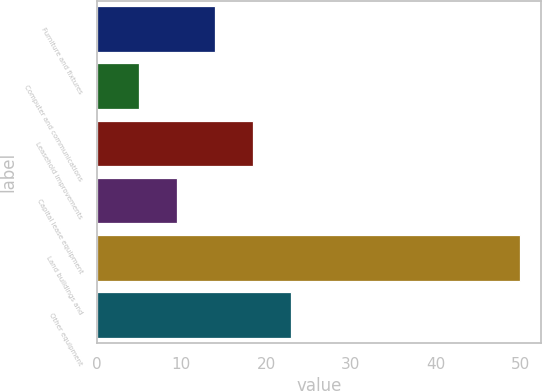<chart> <loc_0><loc_0><loc_500><loc_500><bar_chart><fcel>Furniture and fixtures<fcel>Computer and communications<fcel>Leasehold improvements<fcel>Capital lease equipment<fcel>Land buildings and<fcel>Other equipment<nl><fcel>14<fcel>5<fcel>18.5<fcel>9.5<fcel>50<fcel>23<nl></chart> 